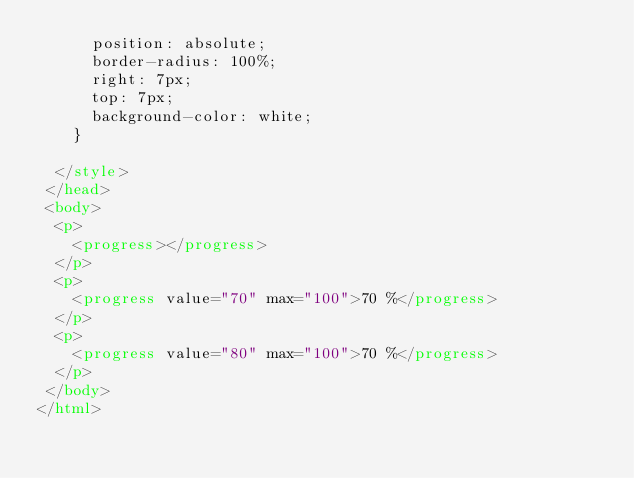<code> <loc_0><loc_0><loc_500><loc_500><_HTML_>      position: absolute;
      border-radius: 100%;
      right: 7px;
      top: 7px;
      background-color: white;
    }

  </style>
 </head>
 <body>
  <p>
    <progress></progress>
  </p>
  <p>
    <progress value="70" max="100">70 %</progress>
  </p>
  <p>
    <progress value="80" max="100">70 %</progress>
  </p>
 </body>
</html>
</code> 